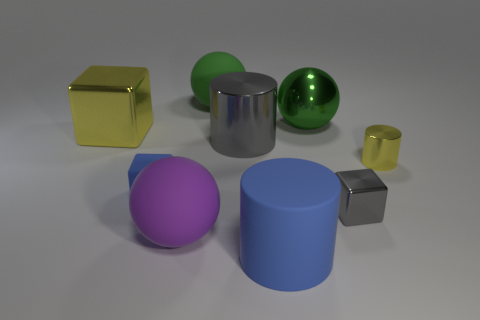Subtract all cubes. How many objects are left? 6 Subtract 0 purple cubes. How many objects are left? 9 Subtract all small yellow metal cylinders. Subtract all large green metallic balls. How many objects are left? 7 Add 1 small cubes. How many small cubes are left? 3 Add 5 big yellow blocks. How many big yellow blocks exist? 6 